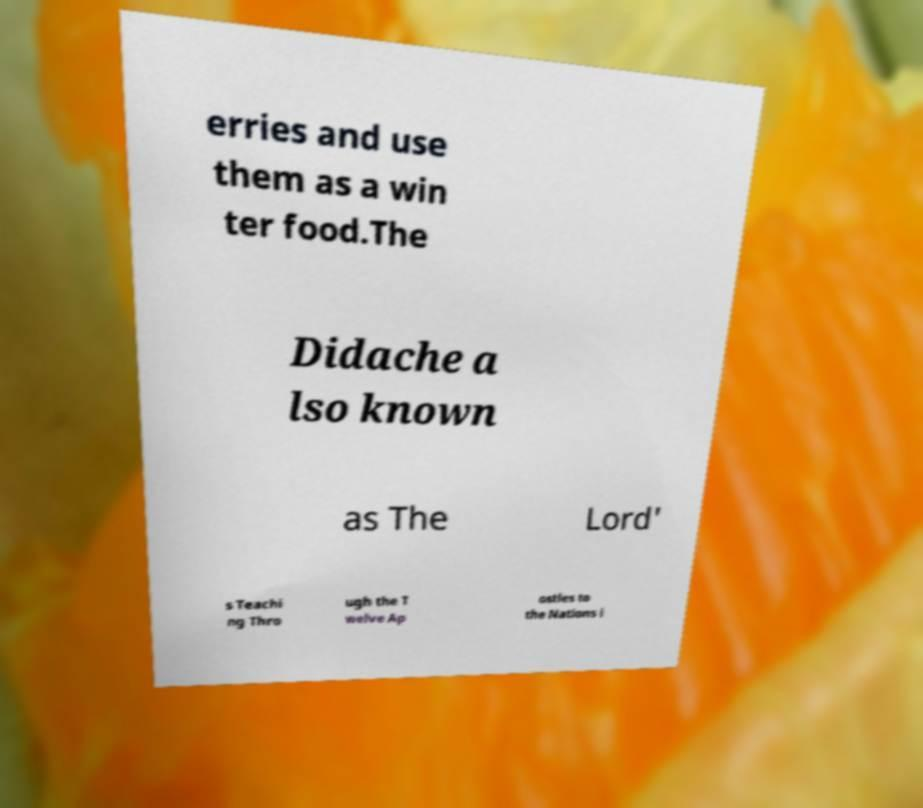Could you assist in decoding the text presented in this image and type it out clearly? erries and use them as a win ter food.The Didache a lso known as The Lord' s Teachi ng Thro ugh the T welve Ap ostles to the Nations i 